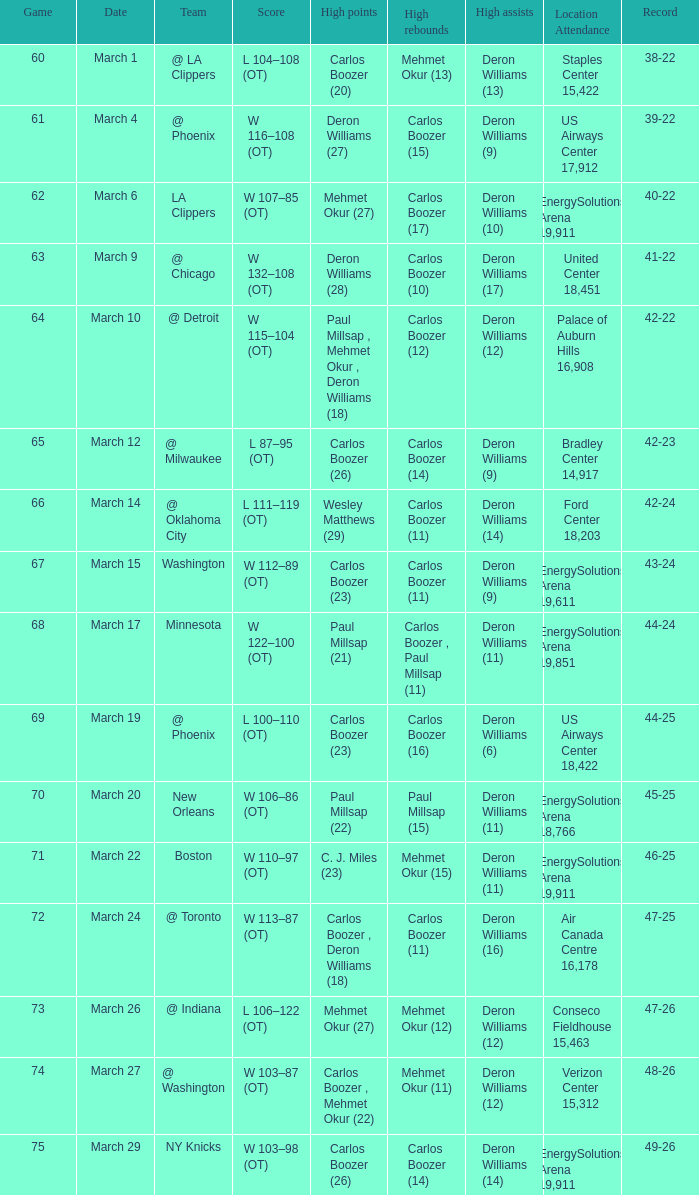How many players did the most high points in the game with 39-22 record? 1.0. 